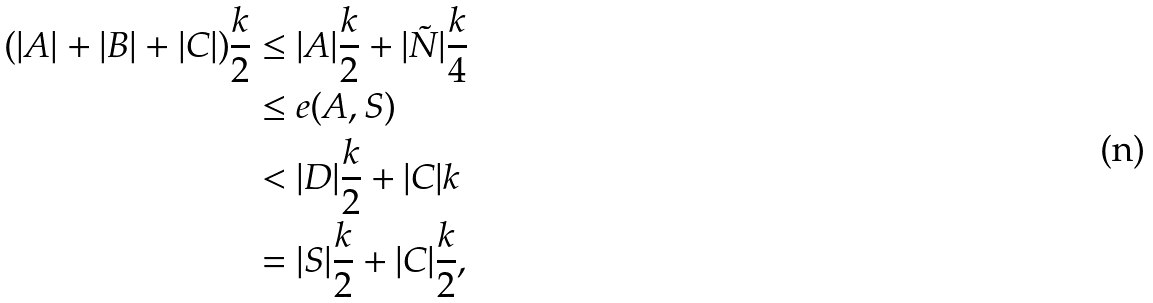Convert formula to latex. <formula><loc_0><loc_0><loc_500><loc_500>( | A | + | B | + | C | ) \frac { k } { 2 } & \leq | A | \frac { k } { 2 } + | \tilde { N } | \frac { k } { 4 } \\ & \leq e ( A , S ) \\ & < | D | \frac { k } { 2 } + | C | k \\ & = | S | \frac { k } { 2 } + | C | \frac { k } { 2 } ,</formula> 